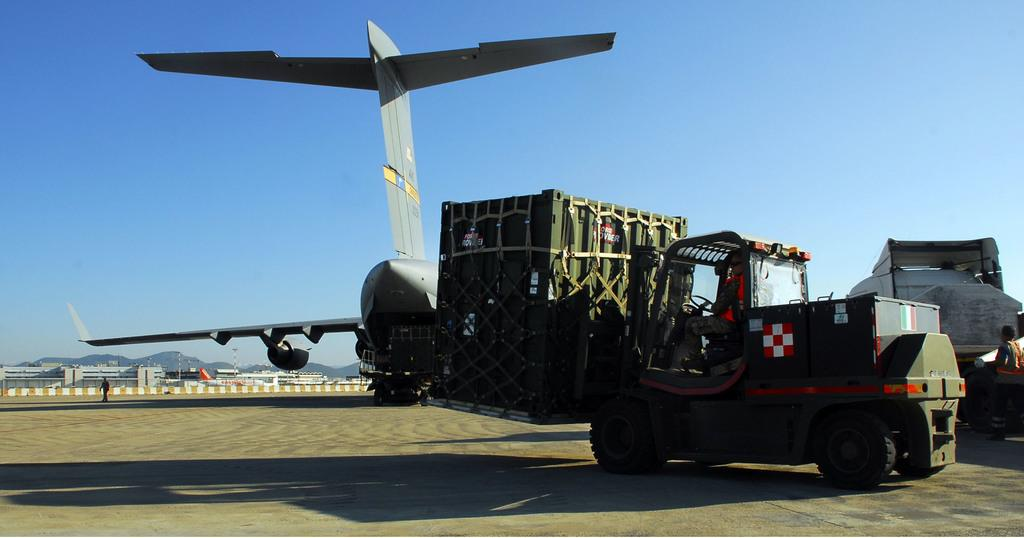What is the main subject of the image? The main subject of the image is an airplane. What else can be seen on the ground in the image? There are vehicles on the ground in the image. Are there any living beings visible in the image? Yes, there are people in the image. What can be seen in the distance in the image? There are mountains visible in the background of the image, along with a fence and other objects. What is visible in the sky in the image? The sky is visible in the background of the image. Can you see a bear holding a spade in the image? No, there is no bear or spade present in the image. Are there any worms visible in the image? No, there are no worms visible in the image. 